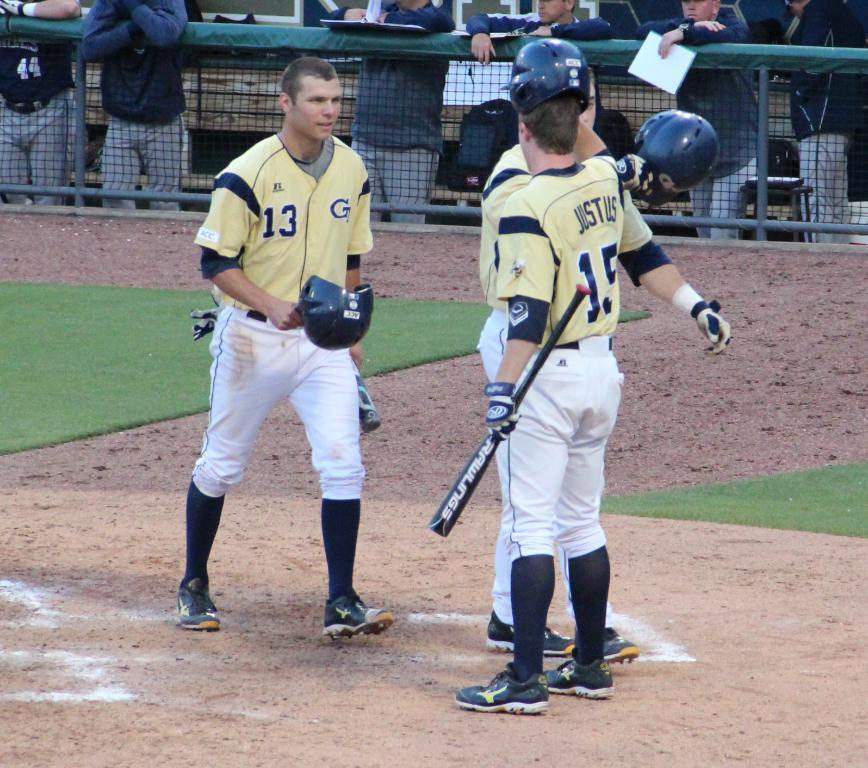<image>
Summarize the visual content of the image. two georgia tech players, #13 and 15 along with another player 